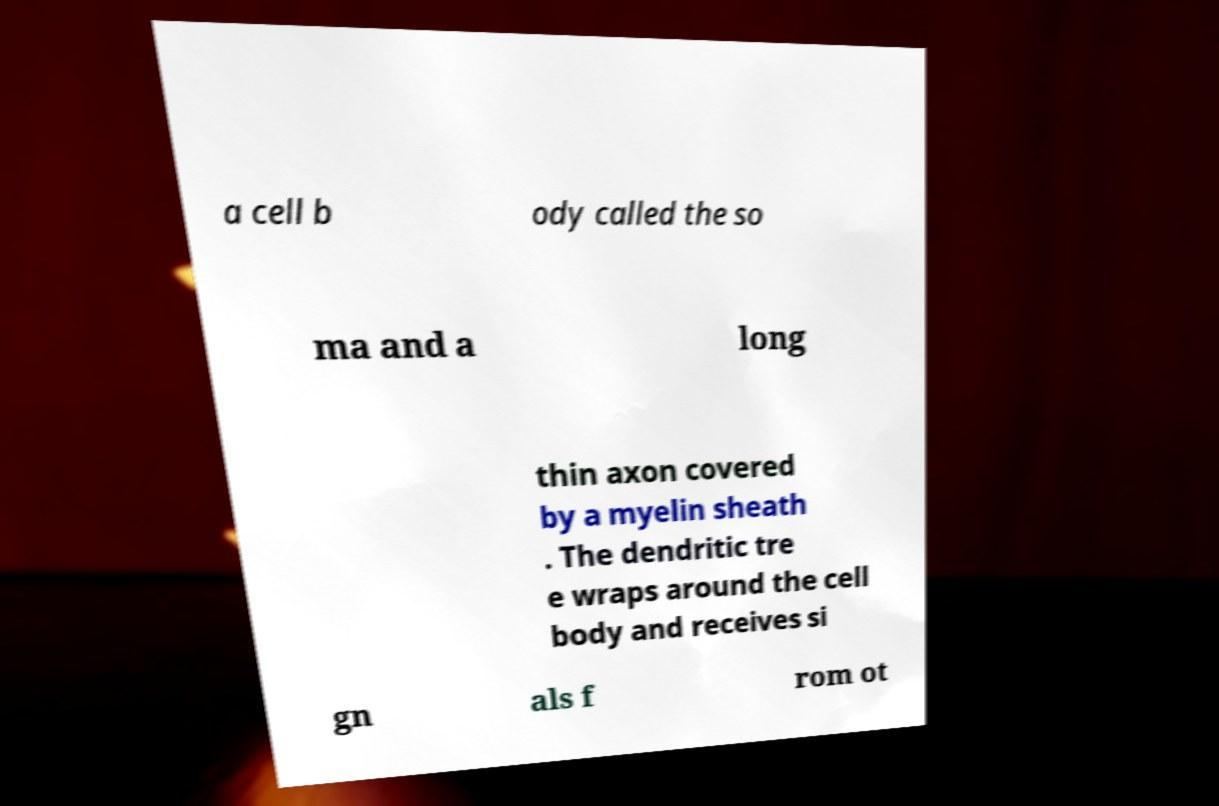Please identify and transcribe the text found in this image. a cell b ody called the so ma and a long thin axon covered by a myelin sheath . The dendritic tre e wraps around the cell body and receives si gn als f rom ot 